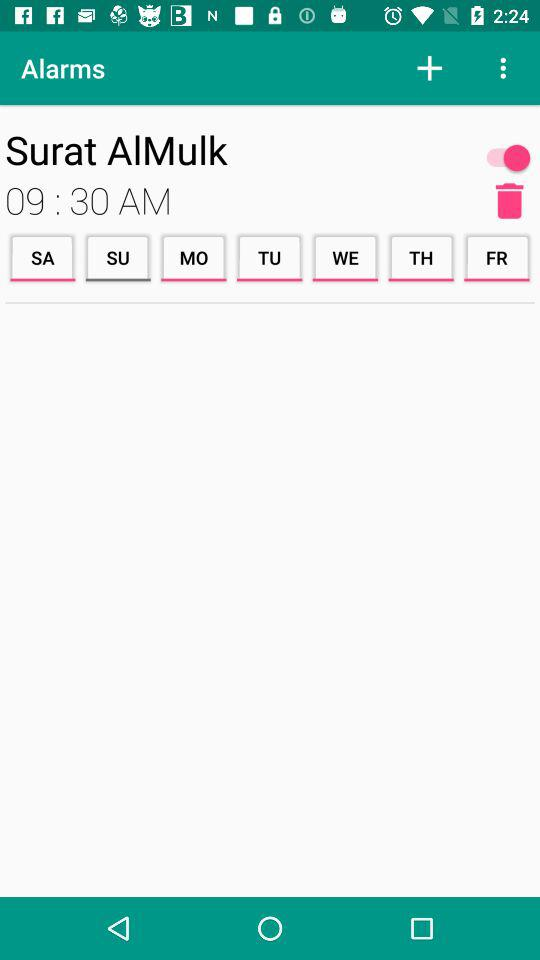Which days are selected for the alarm? The selected days are Saturday, Monday, Tuesday, Wednesday, Thursday and Friday. 